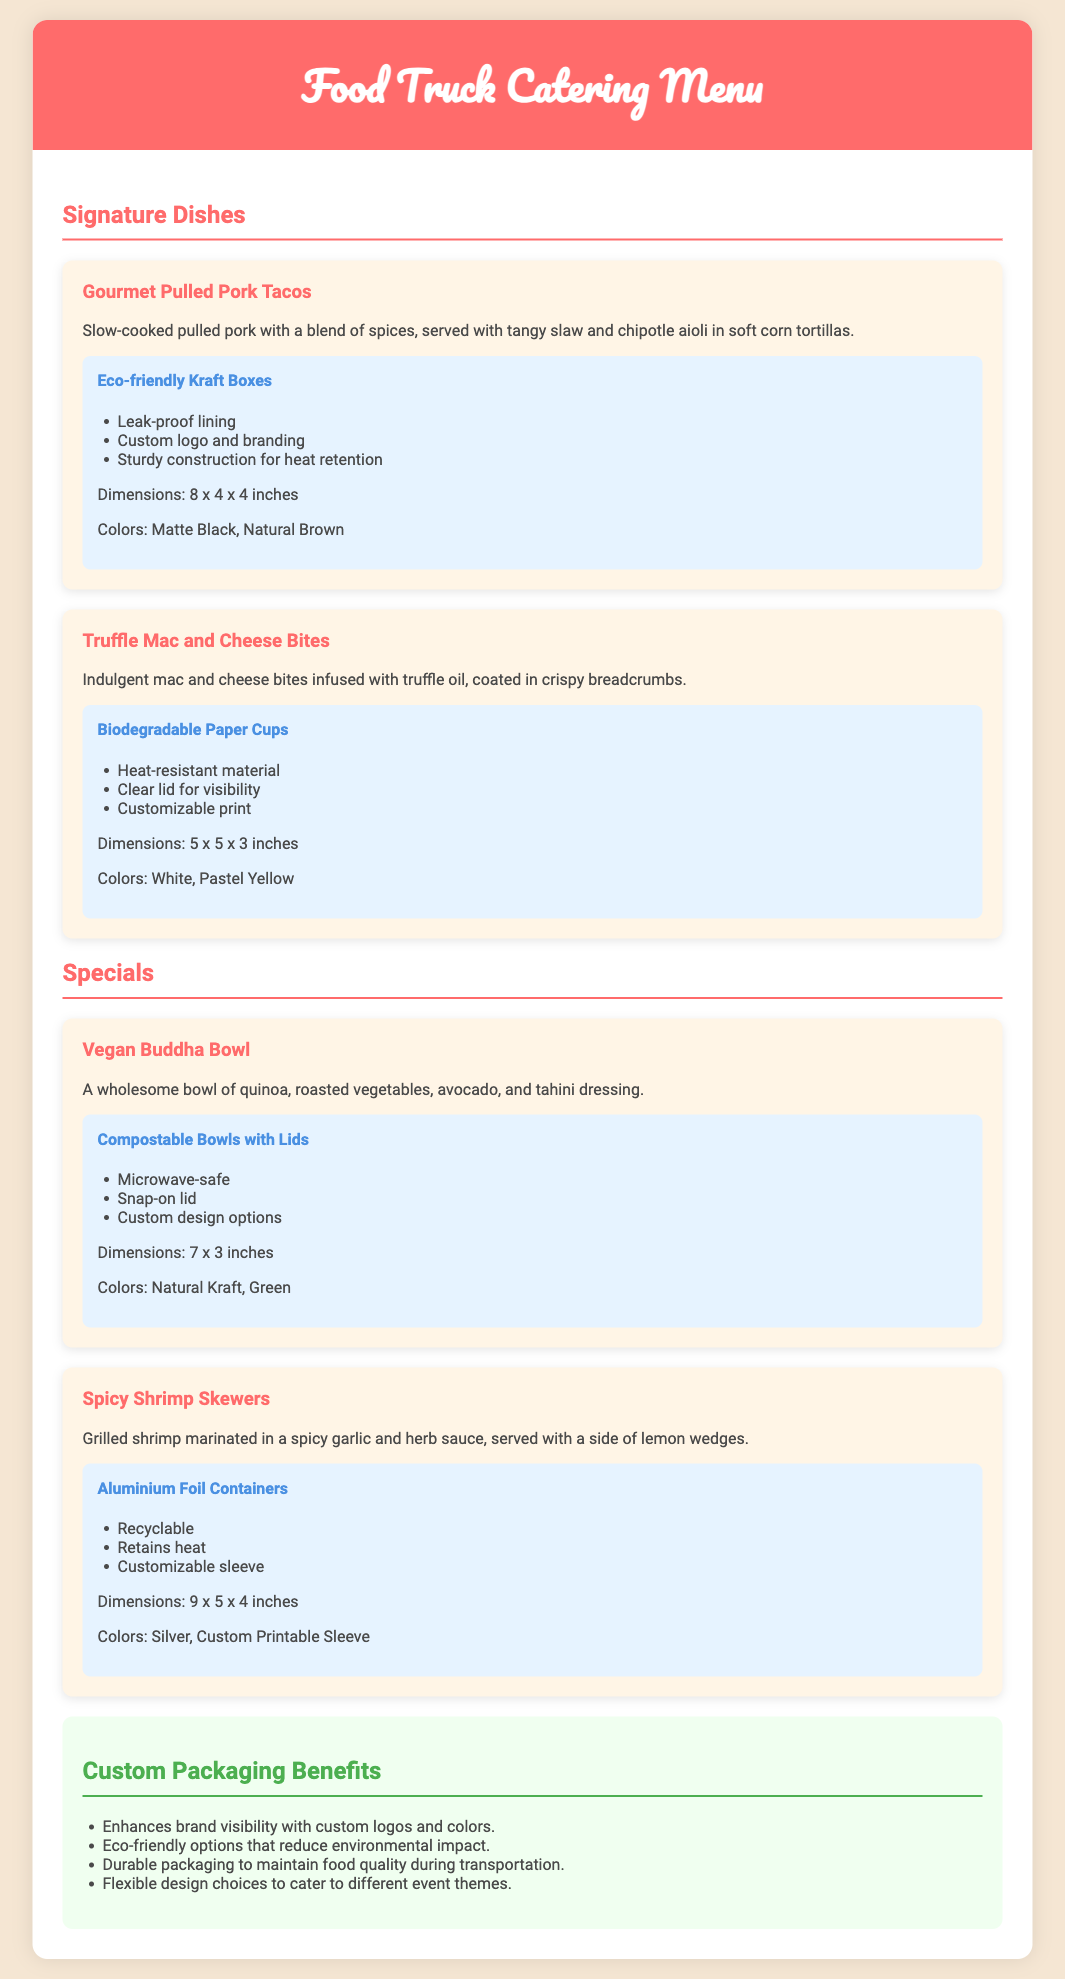What are the dimensions of the Kraft boxes? The dimensions are stated in the packaging section for the Gourmet Pulled Pork Tacos.
Answer: 8 x 4 x 4 inches What type of packaging is used for the Vegan Buddha Bowl? This question refers to the specific packaging mentioned in the document under the Vegan Buddha Bowl dish.
Answer: Compostable Bowls with Lids Which dish is described as having a clear lid for visibility? This refers to the specific packaging details provided for the Truffle Mac and Cheese Bites.
Answer: Truffle Mac and Cheese Bites How many signature dishes are listed in the document? This requires counting the signature dishes section provided in the document.
Answer: Two What color options are available for the Aluminium Foil Containers? This question seeks information about the color choices specified for the Spicy Shrimp Skewers' packaging.
Answer: Silver, Custom Printable Sleeve What is one benefit of custom packaging mentioned in the document? This question focuses on the benefits section and requires identifying one of the listed benefits.
Answer: Enhances brand visibility with custom logos and colors 